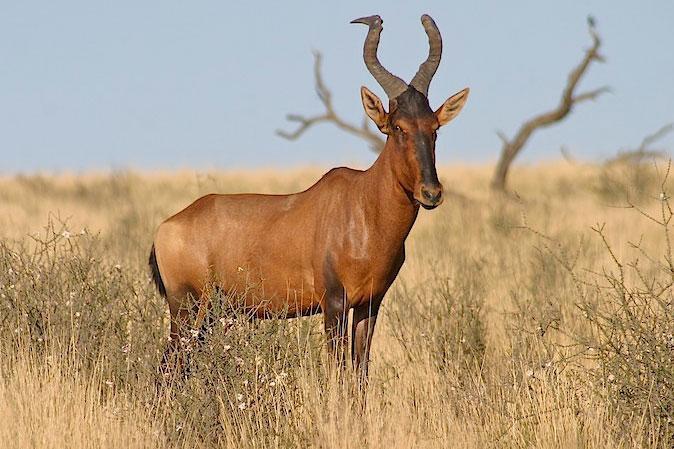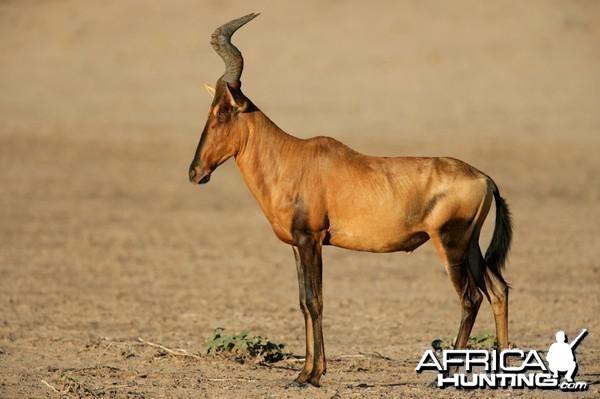The first image is the image on the left, the second image is the image on the right. Considering the images on both sides, is "At least one antelope has its legs up in the air." valid? Answer yes or no. No. 